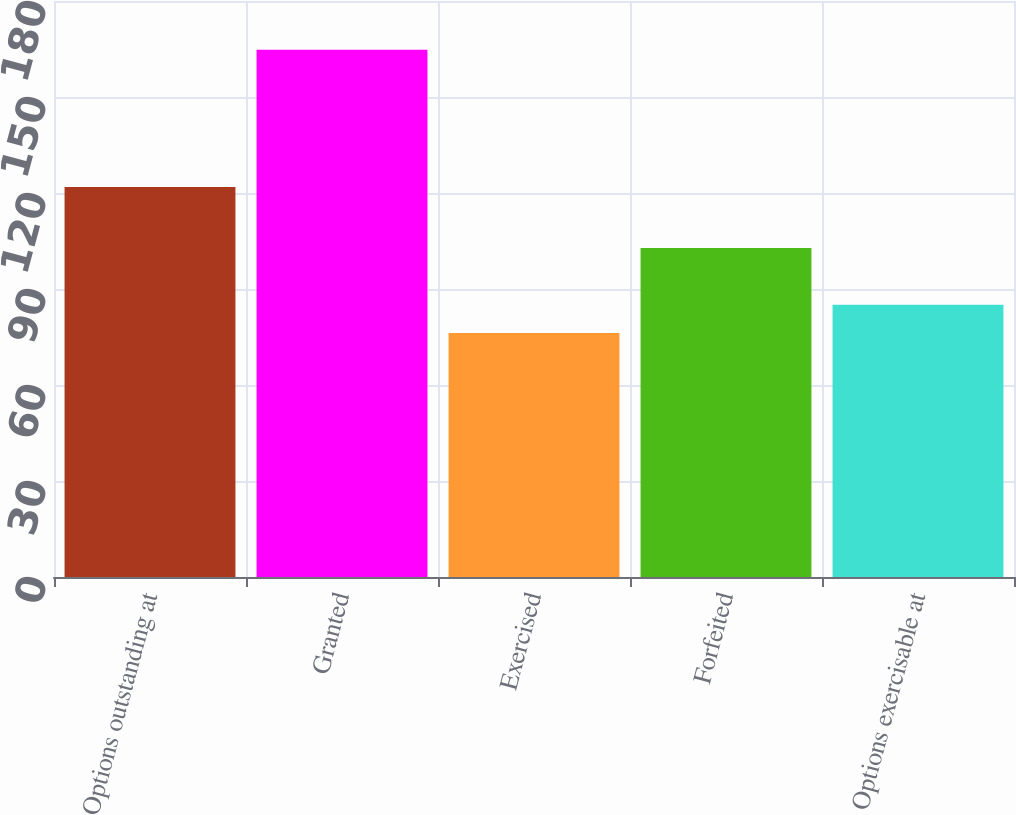Convert chart. <chart><loc_0><loc_0><loc_500><loc_500><bar_chart><fcel>Options outstanding at<fcel>Granted<fcel>Exercised<fcel>Forfeited<fcel>Options exercisable at<nl><fcel>121.89<fcel>164.8<fcel>76.25<fcel>102.83<fcel>85.11<nl></chart> 